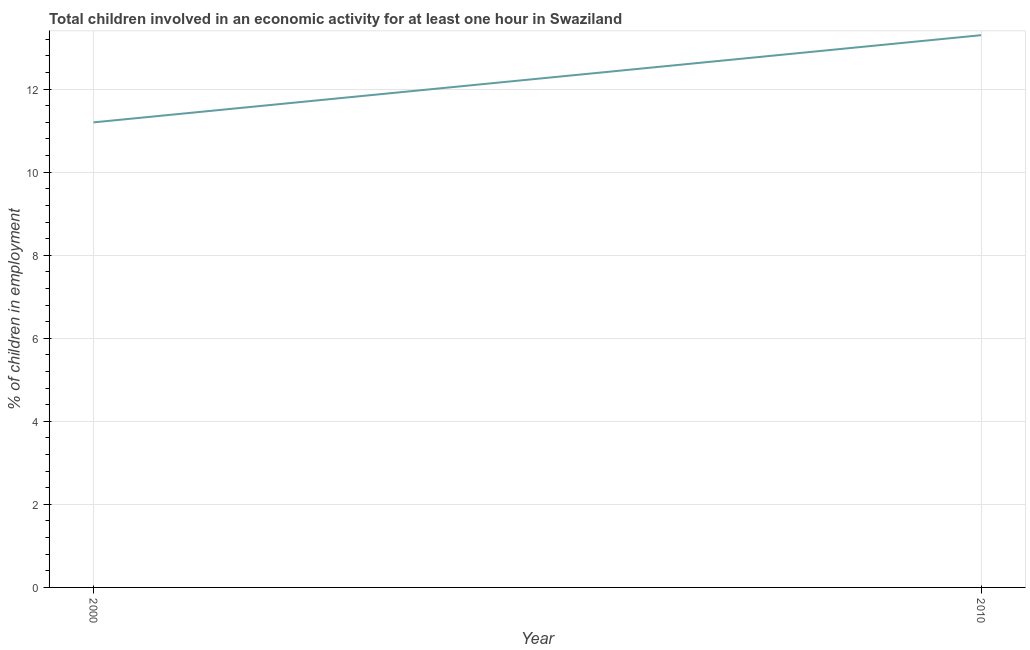What is the percentage of children in employment in 2000?
Your answer should be very brief. 11.2. Across all years, what is the minimum percentage of children in employment?
Provide a short and direct response. 11.2. In which year was the percentage of children in employment minimum?
Your response must be concise. 2000. What is the sum of the percentage of children in employment?
Ensure brevity in your answer.  24.5. What is the difference between the percentage of children in employment in 2000 and 2010?
Your answer should be very brief. -2.1. What is the average percentage of children in employment per year?
Your answer should be very brief. 12.25. What is the median percentage of children in employment?
Offer a terse response. 12.25. In how many years, is the percentage of children in employment greater than 2.8 %?
Provide a succinct answer. 2. Do a majority of the years between 2010 and 2000 (inclusive) have percentage of children in employment greater than 9.2 %?
Ensure brevity in your answer.  No. What is the ratio of the percentage of children in employment in 2000 to that in 2010?
Ensure brevity in your answer.  0.84. Is the percentage of children in employment in 2000 less than that in 2010?
Provide a short and direct response. Yes. Does the percentage of children in employment monotonically increase over the years?
Offer a terse response. Yes. What is the difference between two consecutive major ticks on the Y-axis?
Your response must be concise. 2. Are the values on the major ticks of Y-axis written in scientific E-notation?
Your answer should be compact. No. Does the graph contain any zero values?
Your response must be concise. No. Does the graph contain grids?
Provide a short and direct response. Yes. What is the title of the graph?
Give a very brief answer. Total children involved in an economic activity for at least one hour in Swaziland. What is the label or title of the Y-axis?
Provide a succinct answer. % of children in employment. What is the % of children in employment of 2000?
Your response must be concise. 11.2. What is the % of children in employment in 2010?
Offer a terse response. 13.3. What is the ratio of the % of children in employment in 2000 to that in 2010?
Provide a succinct answer. 0.84. 